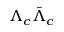Convert formula to latex. <formula><loc_0><loc_0><loc_500><loc_500>\Lambda _ { c } \bar { \Lambda } _ { c }</formula> 